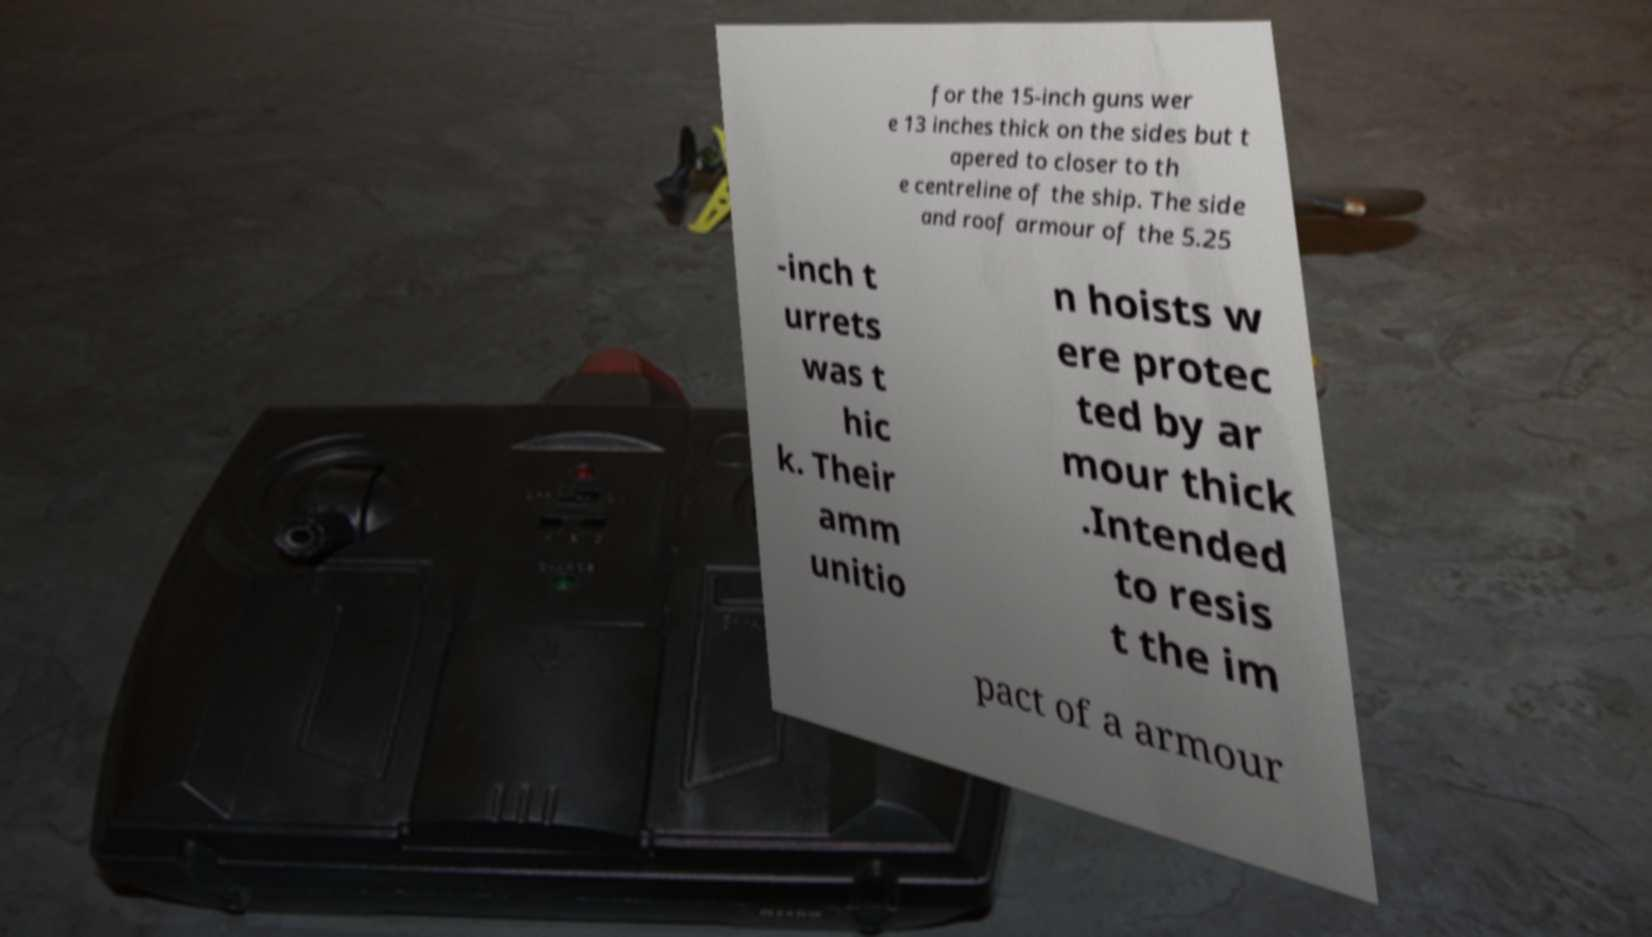Could you extract and type out the text from this image? for the 15-inch guns wer e 13 inches thick on the sides but t apered to closer to th e centreline of the ship. The side and roof armour of the 5.25 -inch t urrets was t hic k. Their amm unitio n hoists w ere protec ted by ar mour thick .Intended to resis t the im pact of a armour 